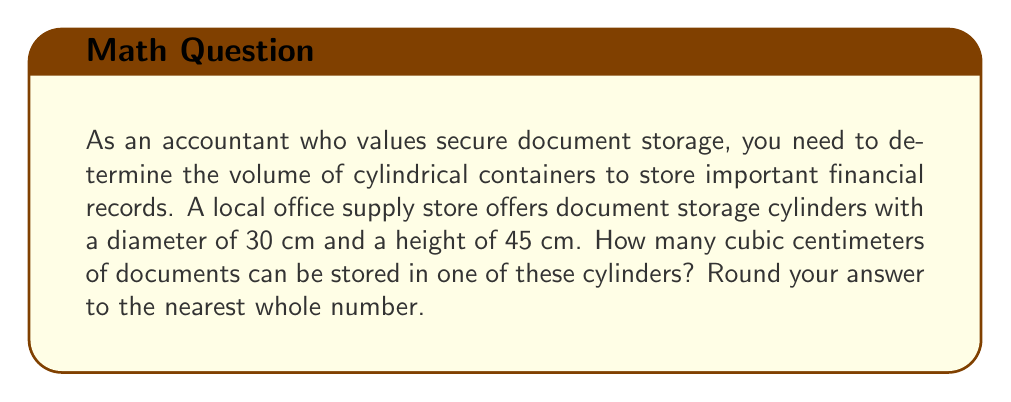Can you answer this question? To solve this problem, we need to use the formula for the volume of a cylinder:

$$V = \pi r^2 h$$

Where:
$V$ = volume
$\pi$ = pi (approximately 3.14159)
$r$ = radius of the base
$h$ = height of the cylinder

Given:
- Diameter = 30 cm
- Height = 45 cm

Step 1: Calculate the radius
The radius is half the diameter:
$r = \frac{30}{2} = 15$ cm

Step 2: Substitute the values into the formula
$$V = \pi (15\text{ cm})^2 (45\text{ cm})$$

Step 3: Calculate
$$\begin{align*}
V &= \pi (225\text{ cm}^2) (45\text{ cm}) \\
&= 31,808.63... \text{ cm}^3
\end{align*}$$

Step 4: Round to the nearest whole number
$31,808.63...\text{ cm}^3 \approx 31,809\text{ cm}^3$

[asy]
import geometry;

size(200);
real r = 3;
real h = 4.5;

path base = circle((0,0),r);
path top = circle((0,h),r);

draw(base);
draw(top);
draw((r,0)--(r,h));
draw((-r,0)--(-r,h));

label("30 cm", (r,h/2), E);
label("45 cm", (0,h/2), W);

[/asy]
Answer: The cylindrical storage container can hold approximately 31,809 cubic centimeters of documents. 